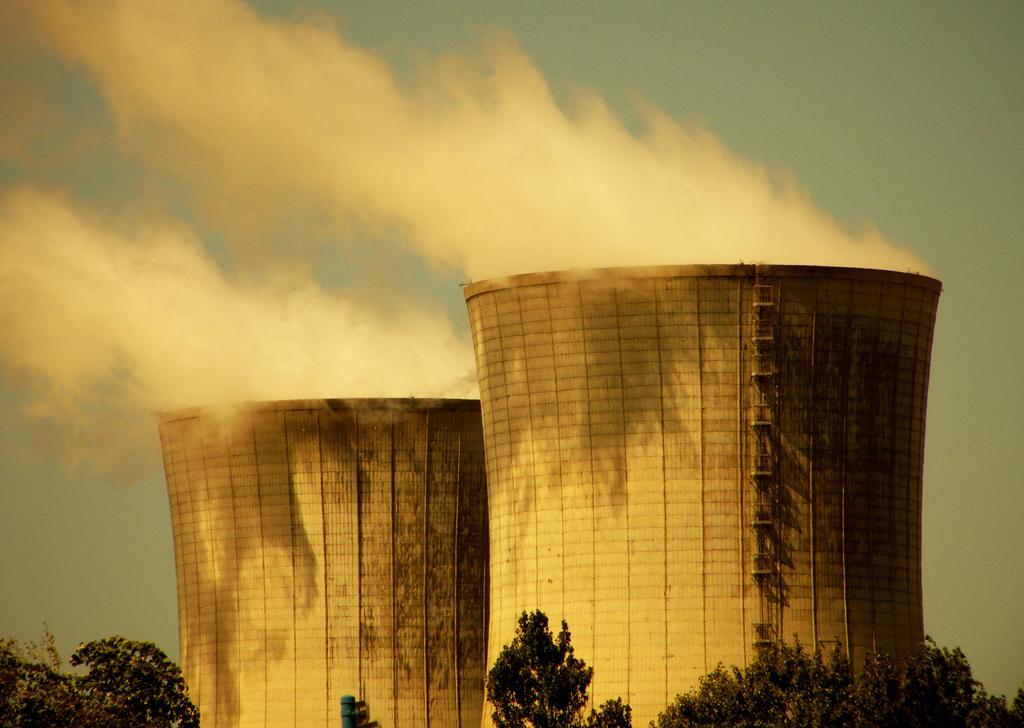How would you summarize this image in a sentence or two? In this image there are two tall buildings. There are trees in the foreground. There are clouds in the sky. 